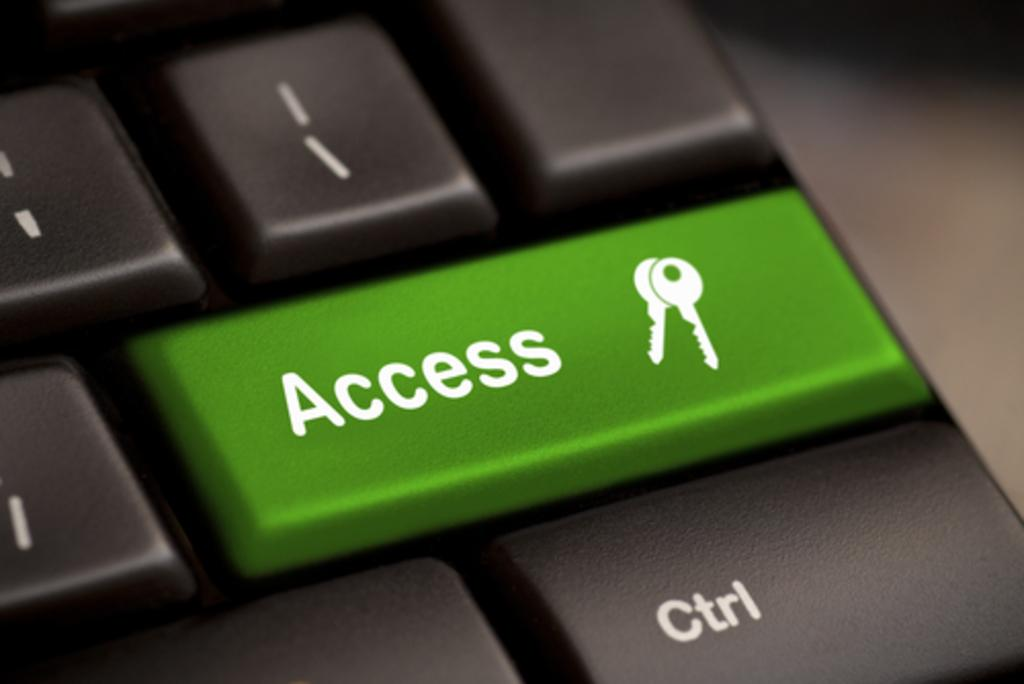<image>
Share a concise interpretation of the image provided. A keyboard with a green Access button above the Ctrl key. 